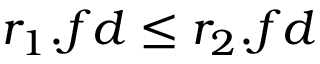Convert formula to latex. <formula><loc_0><loc_0><loc_500><loc_500>r _ { 1 } . f d \leq r _ { 2 } . f d</formula> 